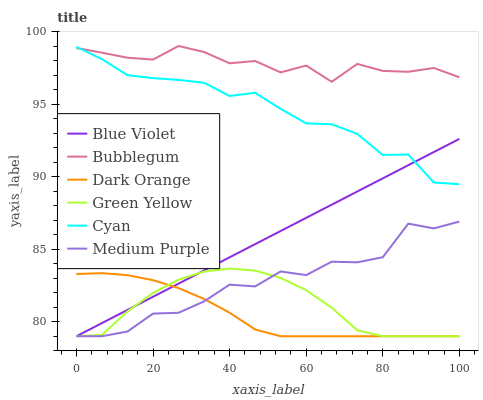Does Dark Orange have the minimum area under the curve?
Answer yes or no. Yes. Does Bubblegum have the maximum area under the curve?
Answer yes or no. Yes. Does Medium Purple have the minimum area under the curve?
Answer yes or no. No. Does Medium Purple have the maximum area under the curve?
Answer yes or no. No. Is Blue Violet the smoothest?
Answer yes or no. Yes. Is Medium Purple the roughest?
Answer yes or no. Yes. Is Bubblegum the smoothest?
Answer yes or no. No. Is Bubblegum the roughest?
Answer yes or no. No. Does Bubblegum have the lowest value?
Answer yes or no. No. Does Medium Purple have the highest value?
Answer yes or no. No. Is Blue Violet less than Bubblegum?
Answer yes or no. Yes. Is Bubblegum greater than Green Yellow?
Answer yes or no. Yes. Does Blue Violet intersect Bubblegum?
Answer yes or no. No. 